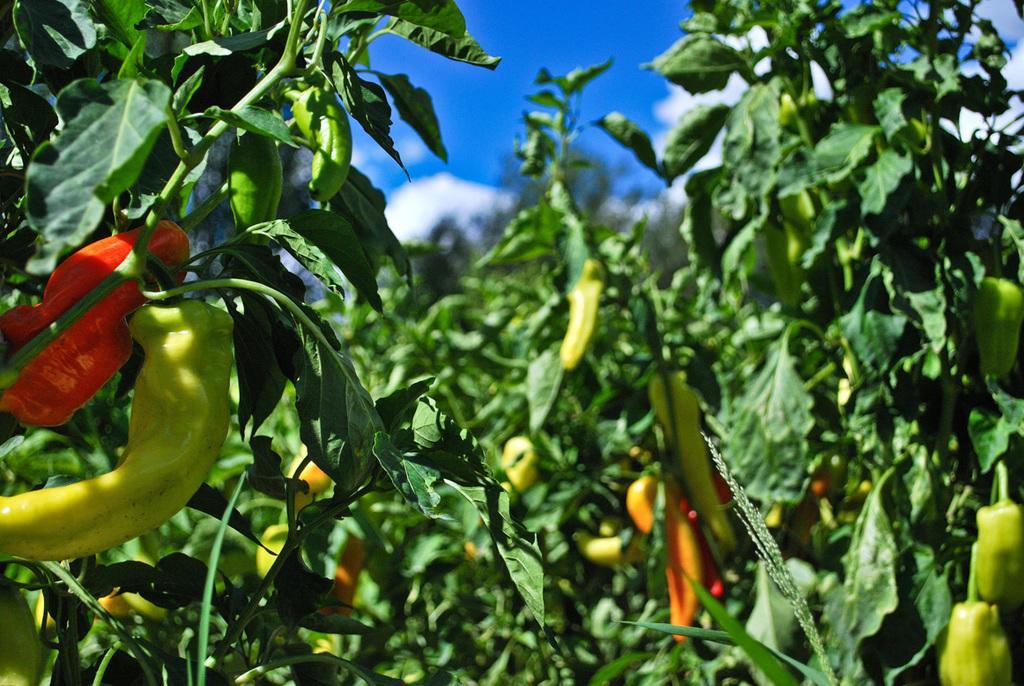In one or two sentences, can you explain what this image depicts? In this picture we can see chilli plants and in the background we can see the sky with clouds. 